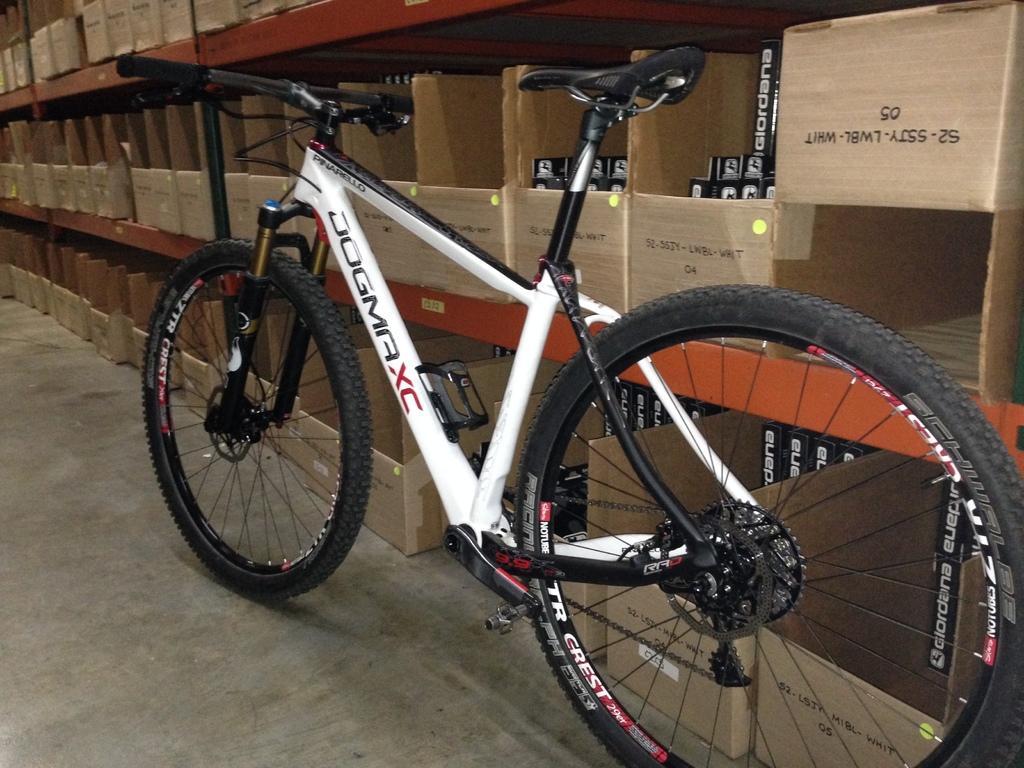In one or two sentences, can you explain what this image depicts? In the foreground I can see a bicycle on the floor. In the background I can see racks in which cartoon boxes are there. This image is taken in a showroom. 